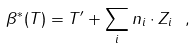Convert formula to latex. <formula><loc_0><loc_0><loc_500><loc_500>\beta ^ { * } ( T ) = T ^ { \prime } + \sum _ { i } n _ { i } \cdot Z _ { i } \ ,</formula> 